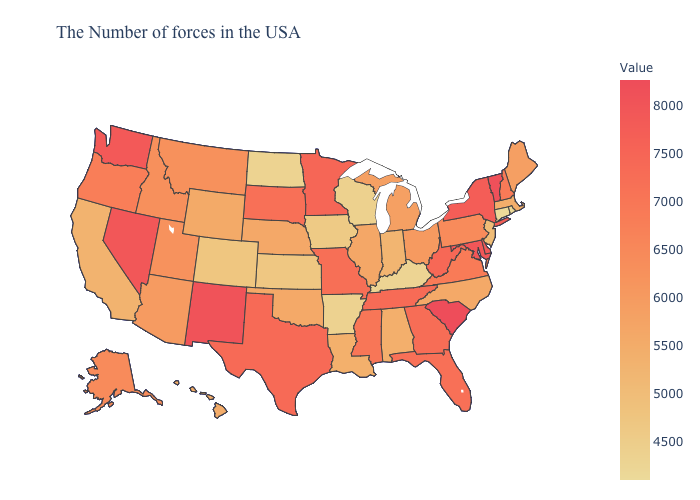Which states have the lowest value in the USA?
Answer briefly. Connecticut. Does South Carolina have the highest value in the USA?
Write a very short answer. Yes. Is the legend a continuous bar?
Give a very brief answer. Yes. Which states have the lowest value in the USA?
Answer briefly. Connecticut. 